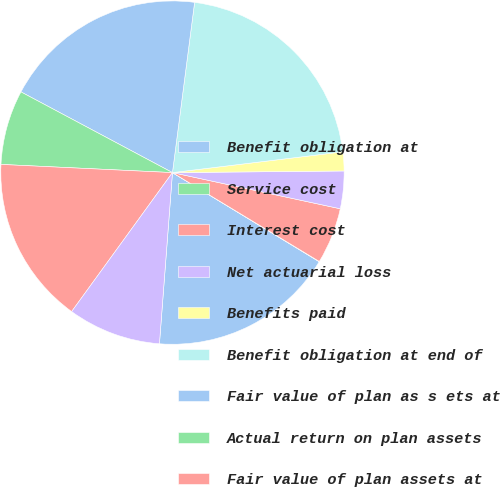<chart> <loc_0><loc_0><loc_500><loc_500><pie_chart><fcel>Benefit obligation at<fcel>Service cost<fcel>Interest cost<fcel>Net actuarial loss<fcel>Benefits paid<fcel>Benefit obligation at end of<fcel>Fair value of plan as s ets at<fcel>Actual return on plan assets<fcel>Fair value of plan assets at<fcel>Funded status of the plan<nl><fcel>17.52%<fcel>0.03%<fcel>5.28%<fcel>3.53%<fcel>1.78%<fcel>21.01%<fcel>19.27%<fcel>7.03%<fcel>15.77%<fcel>8.78%<nl></chart> 